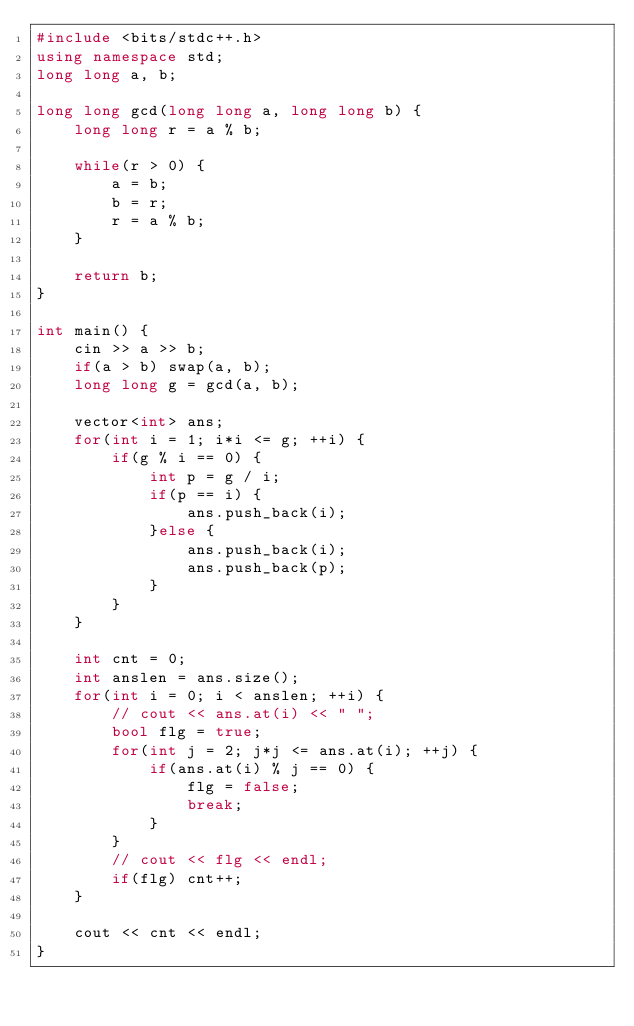Convert code to text. <code><loc_0><loc_0><loc_500><loc_500><_C++_>#include <bits/stdc++.h>
using namespace std;
long long a, b;

long long gcd(long long a, long long b) {
    long long r = a % b;

    while(r > 0) {
        a = b;
        b = r;
        r = a % b;
    }

    return b;
}

int main() {
    cin >> a >> b;
    if(a > b) swap(a, b);
    long long g = gcd(a, b);

    vector<int> ans;
    for(int i = 1; i*i <= g; ++i) {
        if(g % i == 0) {
            int p = g / i;
            if(p == i) {
                ans.push_back(i);
            }else {
                ans.push_back(i);
                ans.push_back(p);
            }
        }
    }

    int cnt = 0;
    int anslen = ans.size();
    for(int i = 0; i < anslen; ++i) {
        // cout << ans.at(i) << " ";
        bool flg = true;
        for(int j = 2; j*j <= ans.at(i); ++j) {
            if(ans.at(i) % j == 0) {
                flg = false;
                break;
            }
        }
        // cout << flg << endl;
        if(flg) cnt++;
    }

    cout << cnt << endl;
}</code> 